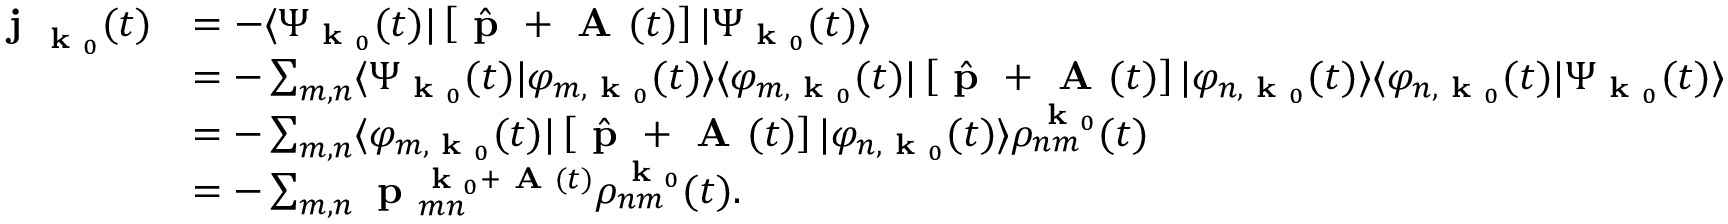Convert formula to latex. <formula><loc_0><loc_0><loc_500><loc_500>\begin{array} { r l } { j _ { k _ { 0 } } ( t ) } & { = - \langle \Psi _ { k _ { 0 } } ( t ) | \left [ \hat { p } + A ( t ) \right ] | \Psi _ { k _ { 0 } } ( t ) \rangle } \\ & { = - \sum _ { m , n } \langle \Psi _ { k _ { 0 } } ( t ) | \varphi _ { m , k _ { 0 } } ( t ) \rangle \langle \varphi _ { m , k _ { 0 } } ( t ) | \left [ \hat { p } + A ( t ) \right ] | \varphi _ { n , k _ { 0 } } ( t ) \rangle \langle \varphi _ { n , k _ { 0 } } ( t ) | \Psi _ { k _ { 0 } } ( t ) \rangle } \\ & { = - \sum _ { m , n } \langle \varphi _ { m , k _ { 0 } } ( t ) | \left [ \hat { p } + A ( t ) \right ] | \varphi _ { n , k _ { 0 } } ( t ) \rangle \rho _ { n m } ^ { k _ { 0 } } ( t ) } \\ & { = - \sum _ { m , n } p _ { m n } ^ { k _ { 0 } + A ( t ) } \rho _ { n m } ^ { k _ { 0 } } ( t ) . } \end{array}</formula> 